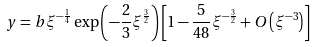<formula> <loc_0><loc_0><loc_500><loc_500>y = b \xi ^ { - \frac { 1 } { 4 } } \exp \left ( - \frac { 2 } { 3 } \xi ^ { \frac { 3 } { 2 } } \right ) \left [ 1 - \frac { 5 } { 4 8 } \xi ^ { - \frac { 3 } { 2 } } + O \left ( \xi ^ { - 3 } \right ) \right ]</formula> 